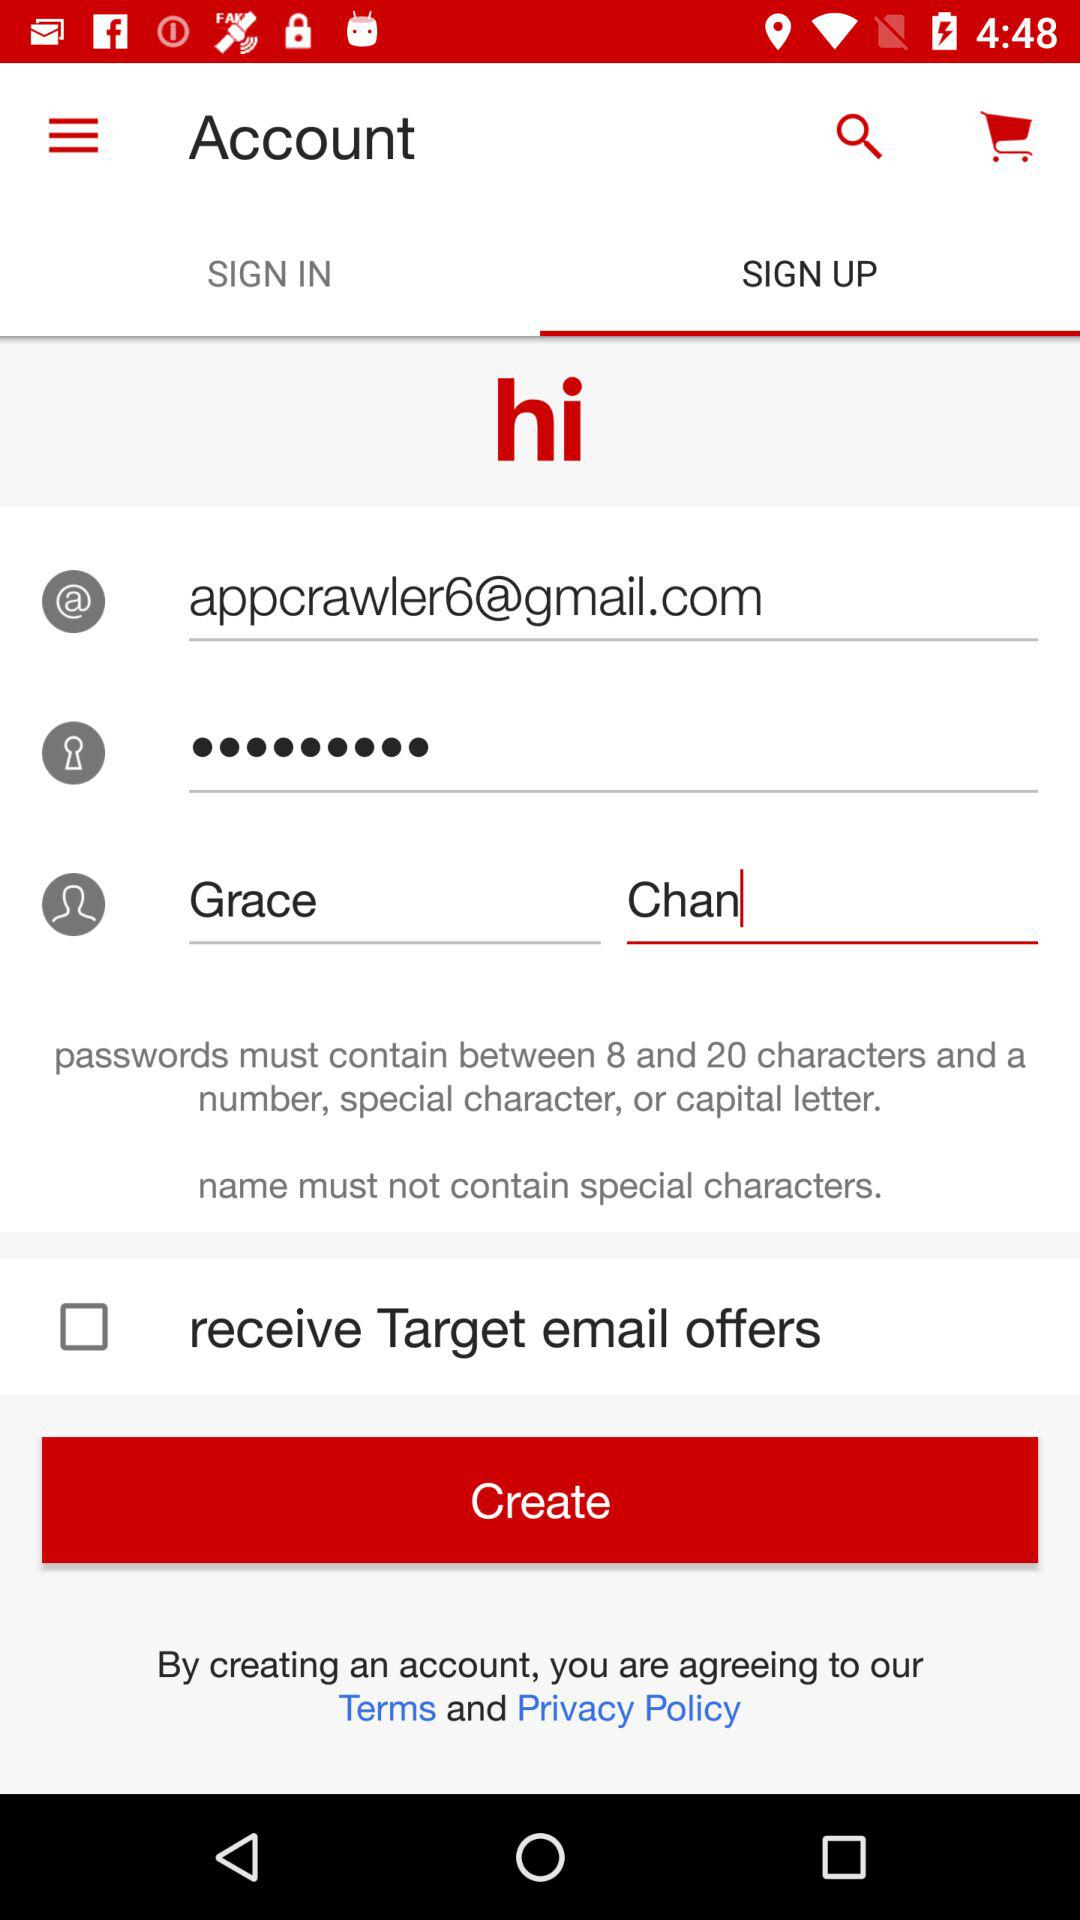How many characters should be in the password? Passwords should contain between 8 and 20 characters. 